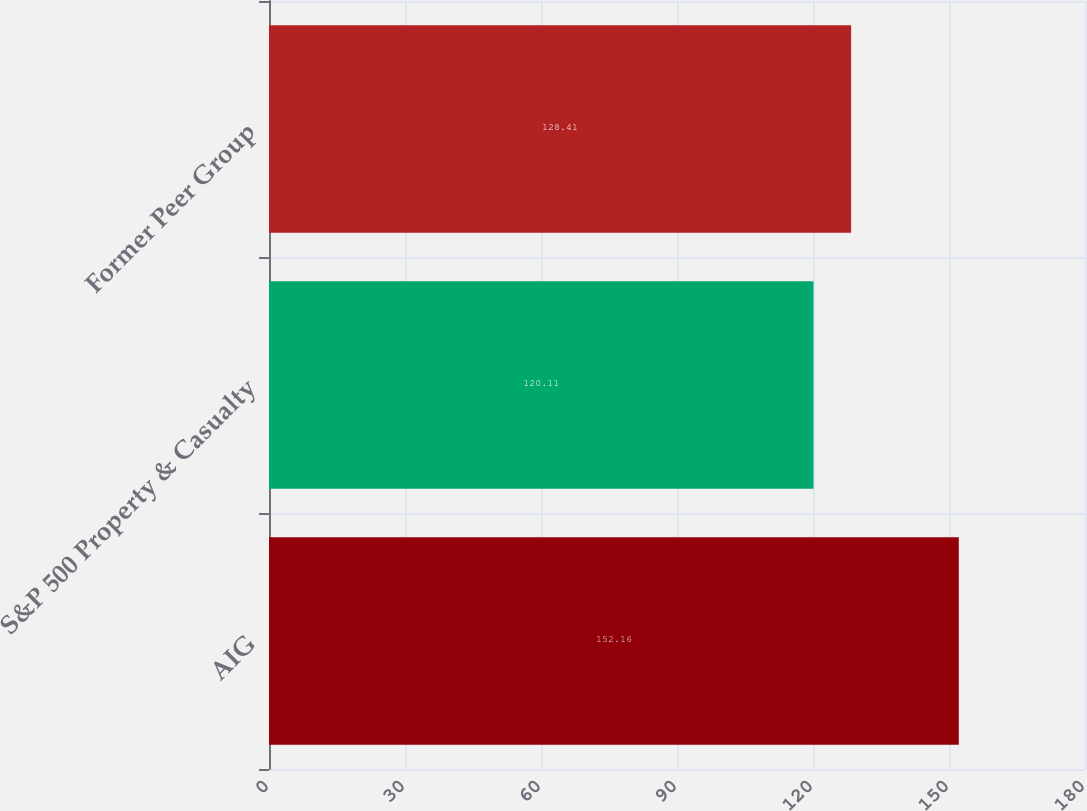Convert chart. <chart><loc_0><loc_0><loc_500><loc_500><bar_chart><fcel>AIG<fcel>S&P 500 Property & Casualty<fcel>Former Peer Group<nl><fcel>152.16<fcel>120.11<fcel>128.41<nl></chart> 